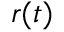Convert formula to latex. <formula><loc_0><loc_0><loc_500><loc_500>r ( t )</formula> 